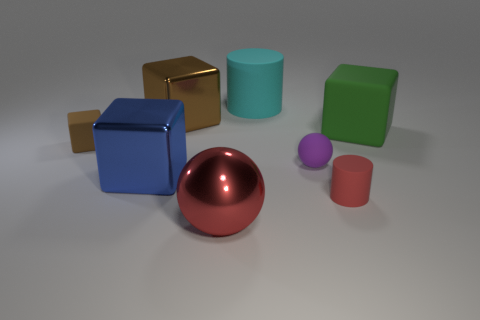Add 1 large cyan rubber things. How many objects exist? 9 Subtract all balls. How many objects are left? 6 Subtract all large spheres. Subtract all large brown spheres. How many objects are left? 7 Add 2 blue metallic objects. How many blue metallic objects are left? 3 Add 6 brown matte spheres. How many brown matte spheres exist? 6 Subtract 1 red cylinders. How many objects are left? 7 